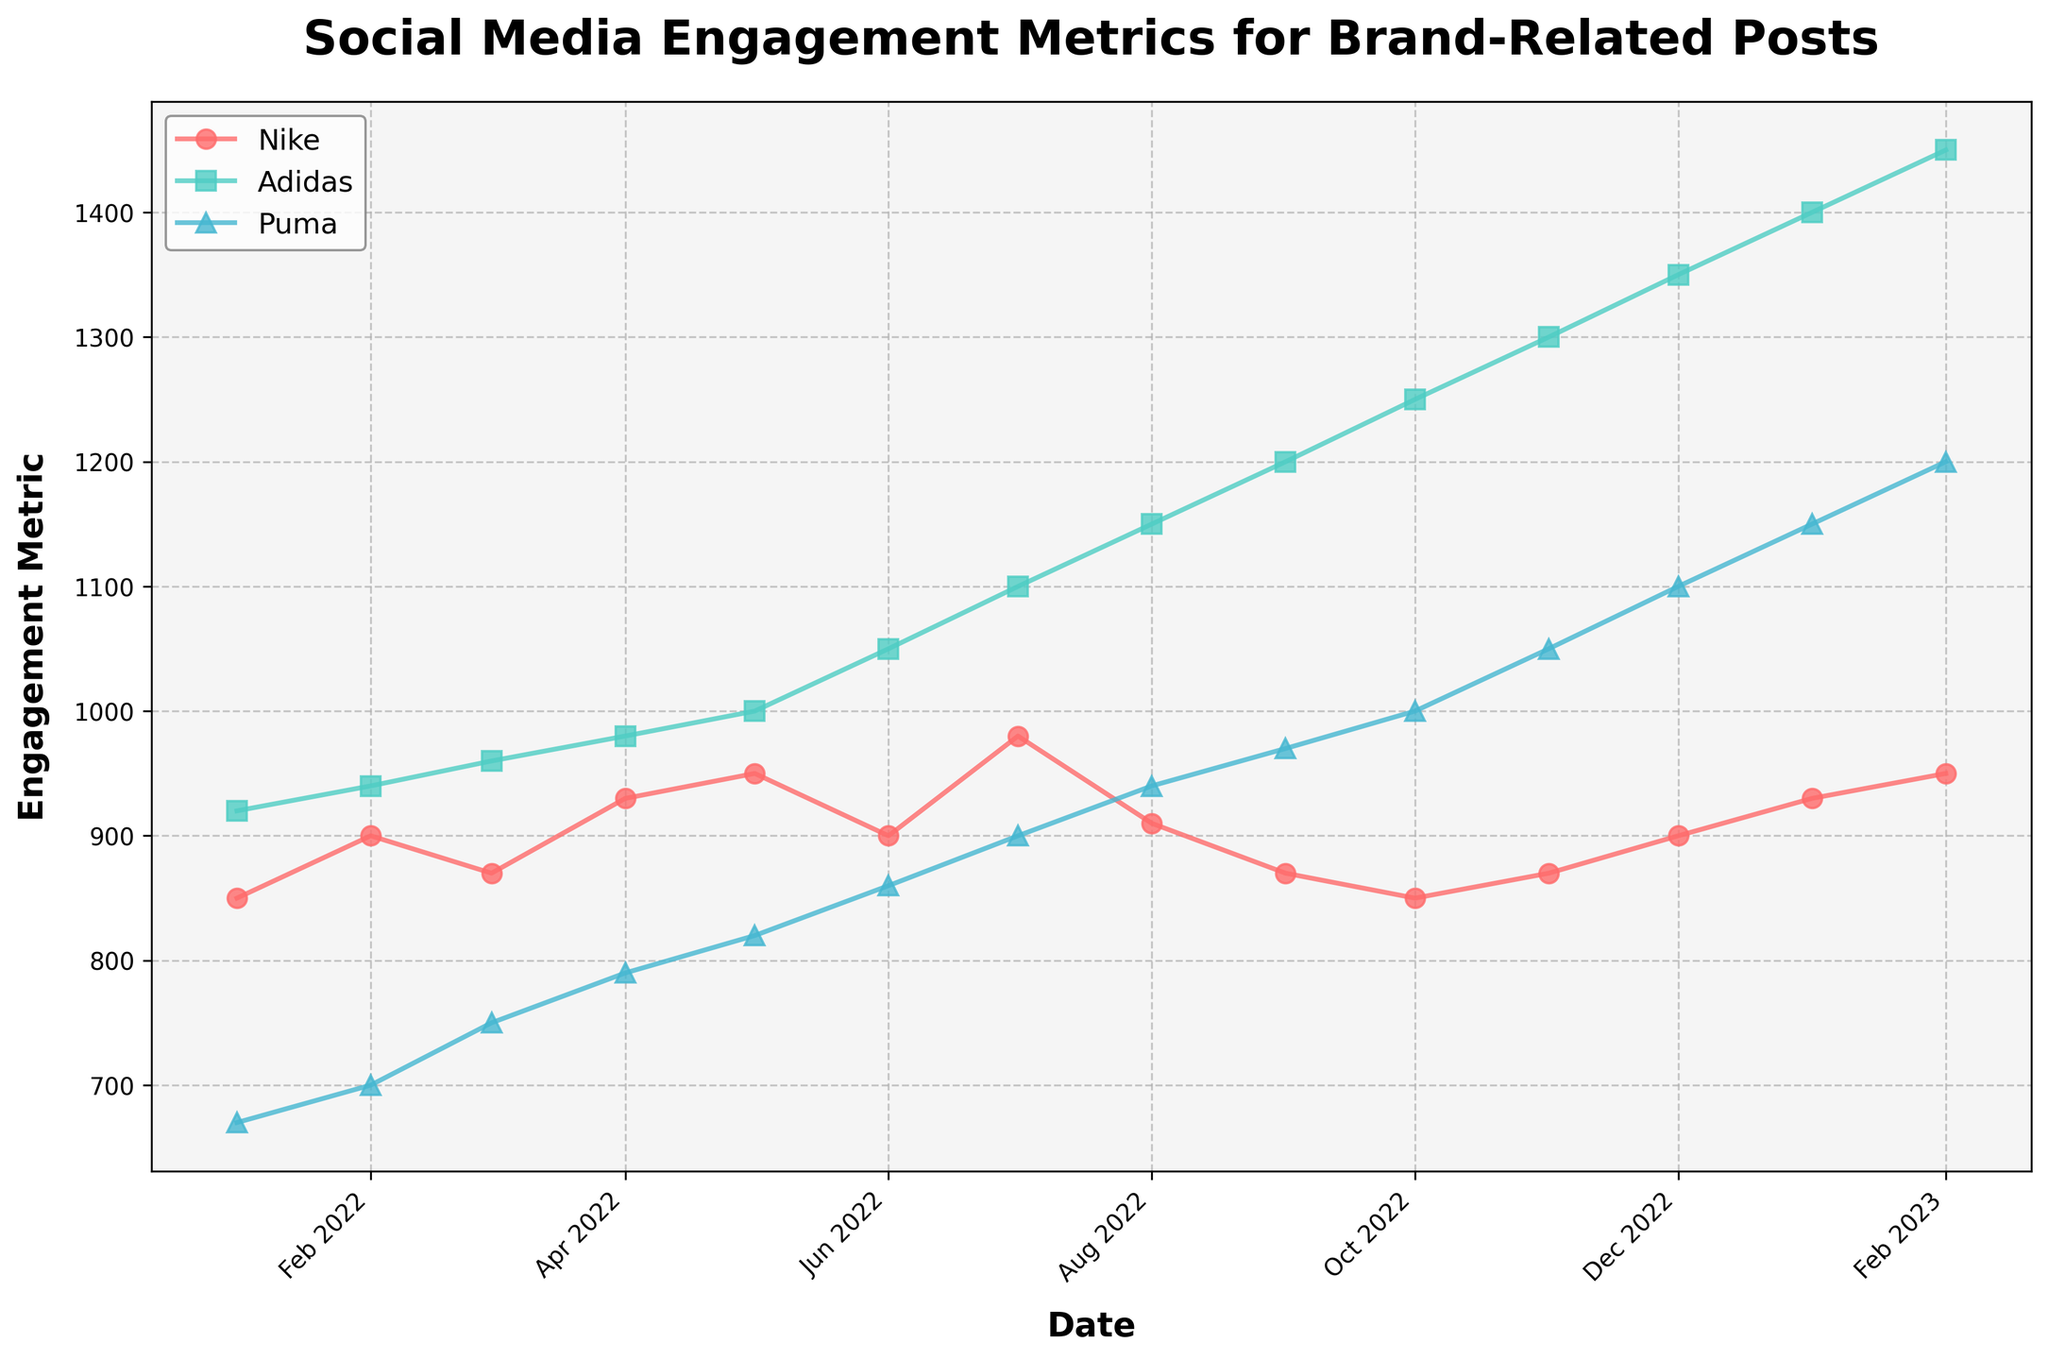What is the title of the figure? The title is prominently displayed at the top of the plot, usually with larger, bold font styling, and it reads "Social Media Engagement Metrics for Brand-Related Posts".
Answer: Social Media Engagement Metrics for Brand-Related Posts Which brand shows the highest engagement metric in December 2022? In December 2022, the plot points for Nike, Adidas, and Puma are all shown. By looking at the topmost point among them, Adidas has the highest engagement metric.
Answer: Adidas How many post types are represented in the figure for each brand? By examining the legend or distinct markers on the plot, one can see that there is only one type of post related to engagement metrics for each brand.
Answer: One Which brand shows a consistent increase in engagement metrics over the entire period? Track the engagement metrics for each brand across all dates. Adidas shows a consistent increase as its engagement metric rises steadily every month.
Answer: Adidas During which month did Nike experience the lowest engagement metric? Find the lowest point on the Nike time series plot. This occurs in October 2022, where the engagement metric for Nike is the lowest at 850.
Answer: October 2022 What is the difference in engagement metrics between Puma and Adidas in February 2023? Locate the points for Puma and Adidas in February 2023. The engagement for Puma is 1200 and for Adidas is 1450, thus the difference is 1450 - 1200 = 250.
Answer: 250 By how much did the engagement metric for Adidas change from January 2022 to February 2023? Determine the engagement metric for Adidas in January 2022 (920) and February 2023 (1450), then compute the change: 1450 - 920 = 530.
Answer: 530 Which month shows the highest engagement metric for Nike, and what is the value? Identify the peak point in the Nike time series. This occurs in July 2022 with a value of 980.
Answer: July 2022, 980 Compare the engagement metric trends for Nike and Puma. Which brand shows more variability over the period? Examine the plot lines for Nike and Puma. Nike's metrics fluctuate more frequently compared to the relatively steadier rise of Puma's engagement metrics.
Answer: Nike Is there any month where all three brands have similar engagement metrics? Compare the engagement metric values for all three brands month by month. In March 2022, the metrics are closest with Nike at 870, Adidas at 960, and Puma at 750.
Answer: March 2022 